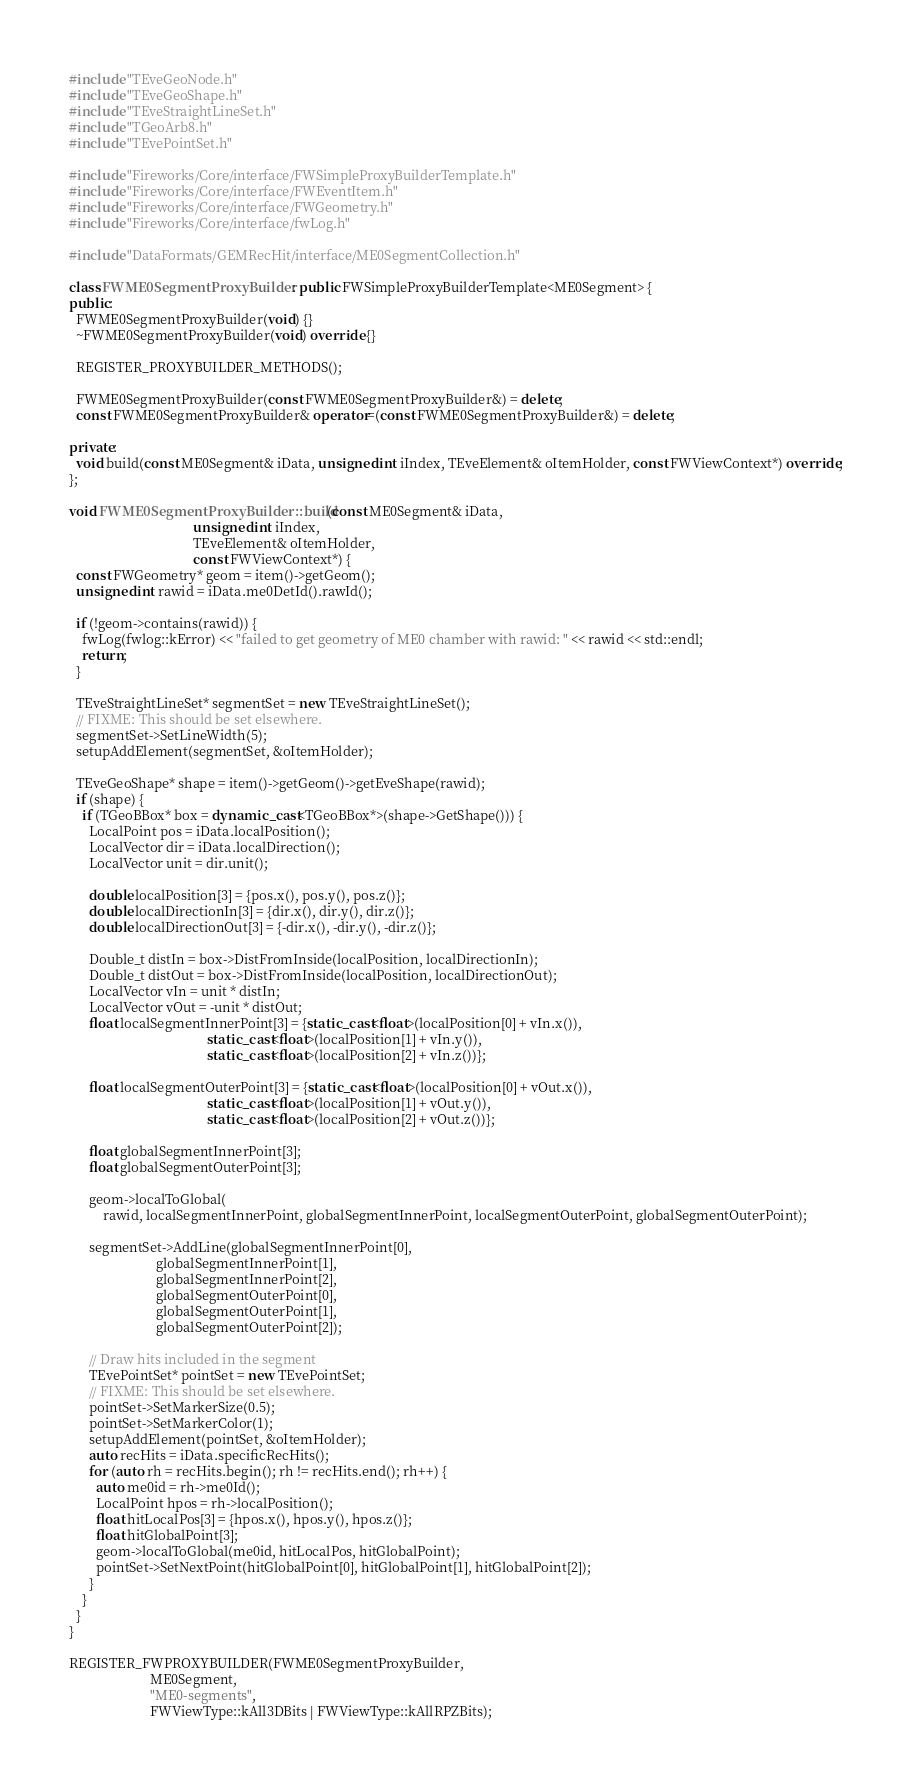Convert code to text. <code><loc_0><loc_0><loc_500><loc_500><_C++_>#include "TEveGeoNode.h"
#include "TEveGeoShape.h"
#include "TEveStraightLineSet.h"
#include "TGeoArb8.h"
#include "TEvePointSet.h"

#include "Fireworks/Core/interface/FWSimpleProxyBuilderTemplate.h"
#include "Fireworks/Core/interface/FWEventItem.h"
#include "Fireworks/Core/interface/FWGeometry.h"
#include "Fireworks/Core/interface/fwLog.h"

#include "DataFormats/GEMRecHit/interface/ME0SegmentCollection.h"

class FWME0SegmentProxyBuilder : public FWSimpleProxyBuilderTemplate<ME0Segment> {
public:
  FWME0SegmentProxyBuilder(void) {}
  ~FWME0SegmentProxyBuilder(void) override {}

  REGISTER_PROXYBUILDER_METHODS();

  FWME0SegmentProxyBuilder(const FWME0SegmentProxyBuilder&) = delete;
  const FWME0SegmentProxyBuilder& operator=(const FWME0SegmentProxyBuilder&) = delete;

private:
  void build(const ME0Segment& iData, unsigned int iIndex, TEveElement& oItemHolder, const FWViewContext*) override;
};

void FWME0SegmentProxyBuilder::build(const ME0Segment& iData,
                                     unsigned int iIndex,
                                     TEveElement& oItemHolder,
                                     const FWViewContext*) {
  const FWGeometry* geom = item()->getGeom();
  unsigned int rawid = iData.me0DetId().rawId();

  if (!geom->contains(rawid)) {
    fwLog(fwlog::kError) << "failed to get geometry of ME0 chamber with rawid: " << rawid << std::endl;
    return;
  }

  TEveStraightLineSet* segmentSet = new TEveStraightLineSet();
  // FIXME: This should be set elsewhere.
  segmentSet->SetLineWidth(5);
  setupAddElement(segmentSet, &oItemHolder);

  TEveGeoShape* shape = item()->getGeom()->getEveShape(rawid);
  if (shape) {
    if (TGeoBBox* box = dynamic_cast<TGeoBBox*>(shape->GetShape())) {
      LocalPoint pos = iData.localPosition();
      LocalVector dir = iData.localDirection();
      LocalVector unit = dir.unit();

      double localPosition[3] = {pos.x(), pos.y(), pos.z()};
      double localDirectionIn[3] = {dir.x(), dir.y(), dir.z()};
      double localDirectionOut[3] = {-dir.x(), -dir.y(), -dir.z()};

      Double_t distIn = box->DistFromInside(localPosition, localDirectionIn);
      Double_t distOut = box->DistFromInside(localPosition, localDirectionOut);
      LocalVector vIn = unit * distIn;
      LocalVector vOut = -unit * distOut;
      float localSegmentInnerPoint[3] = {static_cast<float>(localPosition[0] + vIn.x()),
                                         static_cast<float>(localPosition[1] + vIn.y()),
                                         static_cast<float>(localPosition[2] + vIn.z())};

      float localSegmentOuterPoint[3] = {static_cast<float>(localPosition[0] + vOut.x()),
                                         static_cast<float>(localPosition[1] + vOut.y()),
                                         static_cast<float>(localPosition[2] + vOut.z())};

      float globalSegmentInnerPoint[3];
      float globalSegmentOuterPoint[3];

      geom->localToGlobal(
          rawid, localSegmentInnerPoint, globalSegmentInnerPoint, localSegmentOuterPoint, globalSegmentOuterPoint);

      segmentSet->AddLine(globalSegmentInnerPoint[0],
                          globalSegmentInnerPoint[1],
                          globalSegmentInnerPoint[2],
                          globalSegmentOuterPoint[0],
                          globalSegmentOuterPoint[1],
                          globalSegmentOuterPoint[2]);

      // Draw hits included in the segment
      TEvePointSet* pointSet = new TEvePointSet;
      // FIXME: This should be set elsewhere.
      pointSet->SetMarkerSize(0.5);
      pointSet->SetMarkerColor(1);
      setupAddElement(pointSet, &oItemHolder);
      auto recHits = iData.specificRecHits();
      for (auto rh = recHits.begin(); rh != recHits.end(); rh++) {
        auto me0id = rh->me0Id();
        LocalPoint hpos = rh->localPosition();
        float hitLocalPos[3] = {hpos.x(), hpos.y(), hpos.z()};
        float hitGlobalPoint[3];
        geom->localToGlobal(me0id, hitLocalPos, hitGlobalPoint);
        pointSet->SetNextPoint(hitGlobalPoint[0], hitGlobalPoint[1], hitGlobalPoint[2]);
      }
    }
  }
}

REGISTER_FWPROXYBUILDER(FWME0SegmentProxyBuilder,
                        ME0Segment,
                        "ME0-segments",
                        FWViewType::kAll3DBits | FWViewType::kAllRPZBits);
</code> 